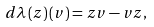Convert formula to latex. <formula><loc_0><loc_0><loc_500><loc_500>d \lambda \left ( z \right ) \left ( v \right ) = z v - v z ,</formula> 